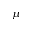Convert formula to latex. <formula><loc_0><loc_0><loc_500><loc_500>\mu</formula> 